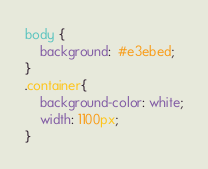Convert code to text. <code><loc_0><loc_0><loc_500><loc_500><_CSS_>body {
	background:  #e3ebed;
}
.container{
	background-color: white;
	width: 1100px;	
}
</code> 